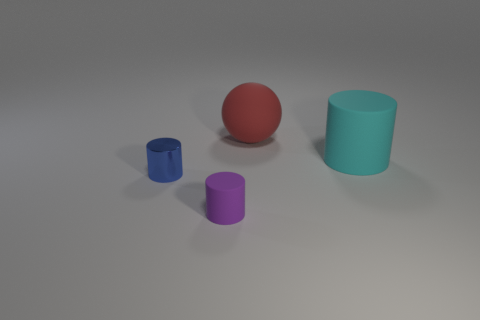What material is the blue object that is the same size as the purple thing?
Your answer should be very brief. Metal. What shape is the matte thing that is the same size as the cyan matte cylinder?
Keep it short and to the point. Sphere. There is a large cyan thing that is made of the same material as the purple cylinder; what is its shape?
Ensure brevity in your answer.  Cylinder. Are there fewer purple rubber cylinders that are on the left side of the purple cylinder than matte objects that are in front of the metal cylinder?
Ensure brevity in your answer.  Yes. Is the number of purple rubber cylinders greater than the number of brown metal spheres?
Offer a very short reply. Yes. What is the blue cylinder made of?
Keep it short and to the point. Metal. What is the color of the tiny cylinder behind the small purple cylinder?
Make the answer very short. Blue. Is the number of big rubber objects on the right side of the big red rubber object greater than the number of red matte objects in front of the metallic cylinder?
Your response must be concise. Yes. How big is the matte cylinder that is left of the cylinder right of the matte thing that is in front of the shiny cylinder?
Give a very brief answer. Small. How many blocks are there?
Provide a succinct answer. 0. 